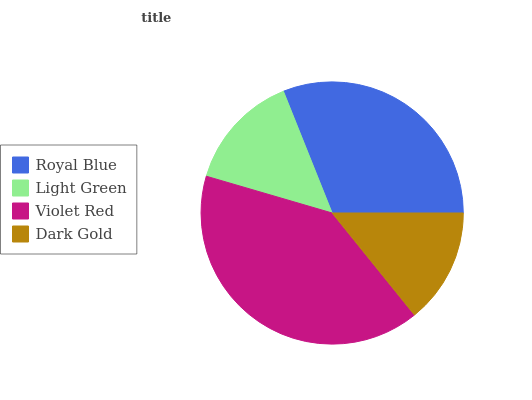Is Dark Gold the minimum?
Answer yes or no. Yes. Is Violet Red the maximum?
Answer yes or no. Yes. Is Light Green the minimum?
Answer yes or no. No. Is Light Green the maximum?
Answer yes or no. No. Is Royal Blue greater than Light Green?
Answer yes or no. Yes. Is Light Green less than Royal Blue?
Answer yes or no. Yes. Is Light Green greater than Royal Blue?
Answer yes or no. No. Is Royal Blue less than Light Green?
Answer yes or no. No. Is Royal Blue the high median?
Answer yes or no. Yes. Is Light Green the low median?
Answer yes or no. Yes. Is Violet Red the high median?
Answer yes or no. No. Is Dark Gold the low median?
Answer yes or no. No. 